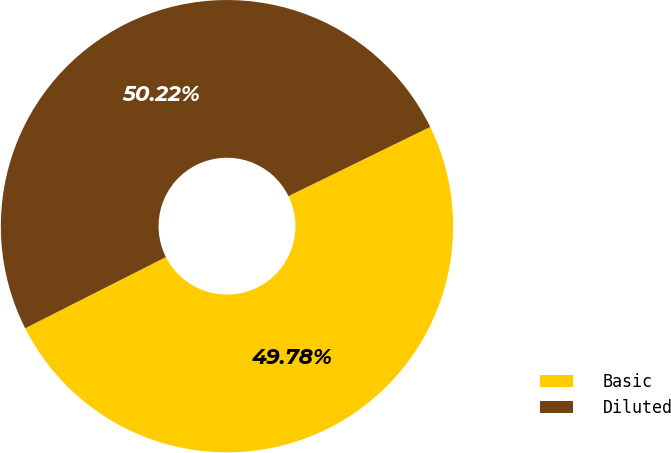Convert chart. <chart><loc_0><loc_0><loc_500><loc_500><pie_chart><fcel>Basic<fcel>Diluted<nl><fcel>49.78%<fcel>50.22%<nl></chart> 